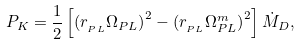Convert formula to latex. <formula><loc_0><loc_0><loc_500><loc_500>P _ { K } = \frac { 1 } { 2 } \left [ { \left ( { r _ { _ { P L } } \Omega _ { P L } } \right ) ^ { 2 } - \left ( { r _ { _ { P L } } \Omega _ { P L } ^ { m } } \right ) ^ { 2 } } \right ] \dot { M } _ { D } ,</formula> 